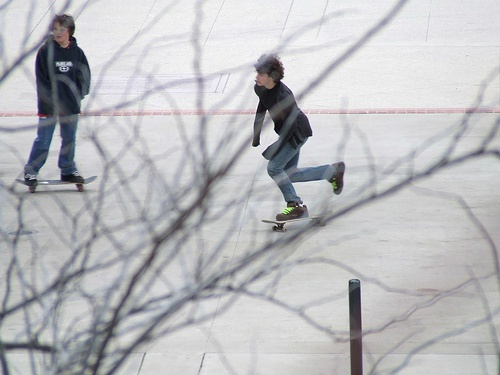Describe the objects in this image and their specific colors. I can see people in lightgray, black, gray, navy, and darkblue tones, people in lightgray, gray, black, and darkgray tones, skateboard in lightgray, darkgray, and gray tones, and skateboard in lightgray, gray, darkgray, and black tones in this image. 